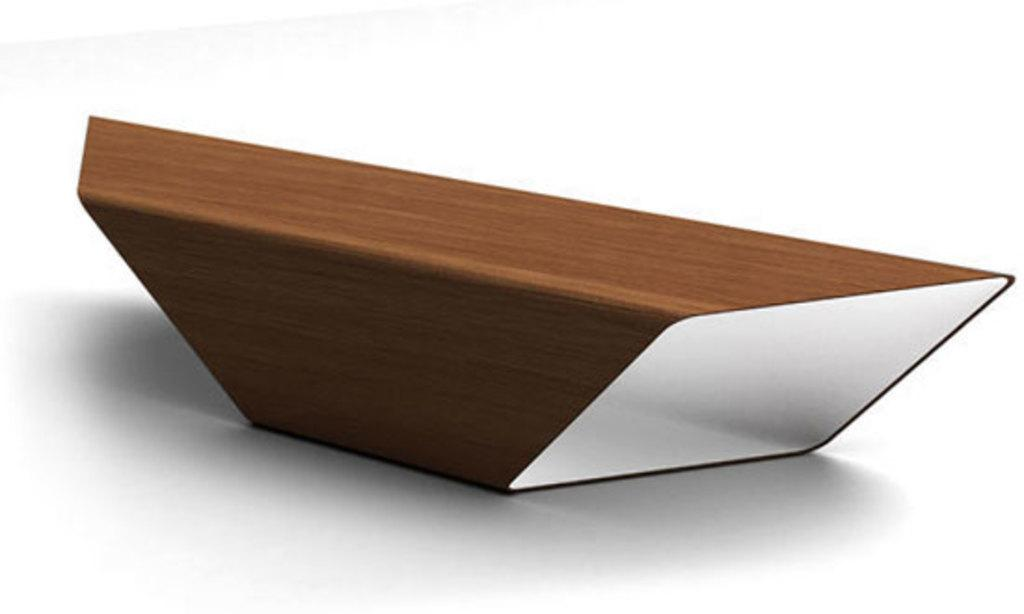What type of table is visible in the image? There is a wooden table in the image. How many roses are growing under the table in the image? There are no roses or any plants mentioned in the image; it only features a wooden table. 